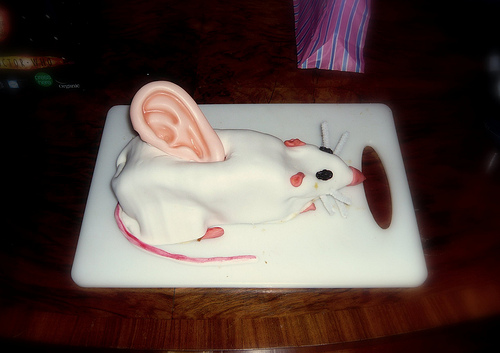<image>
Can you confirm if the mouse is under the cutting board? No. The mouse is not positioned under the cutting board. The vertical relationship between these objects is different. Is there a cake in front of the bag? Yes. The cake is positioned in front of the bag, appearing closer to the camera viewpoint. 